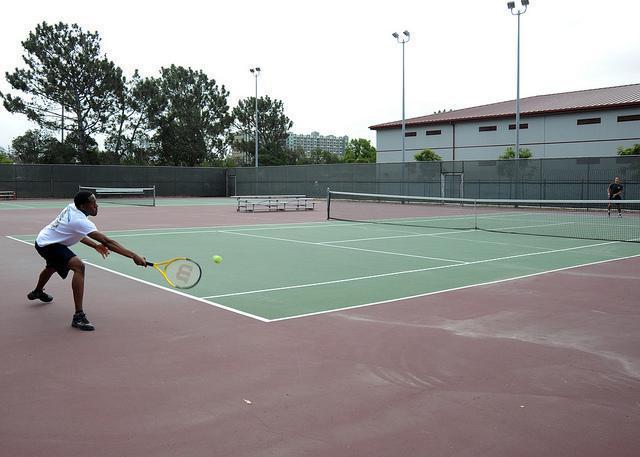How many people are playing?
Give a very brief answer. 2. 